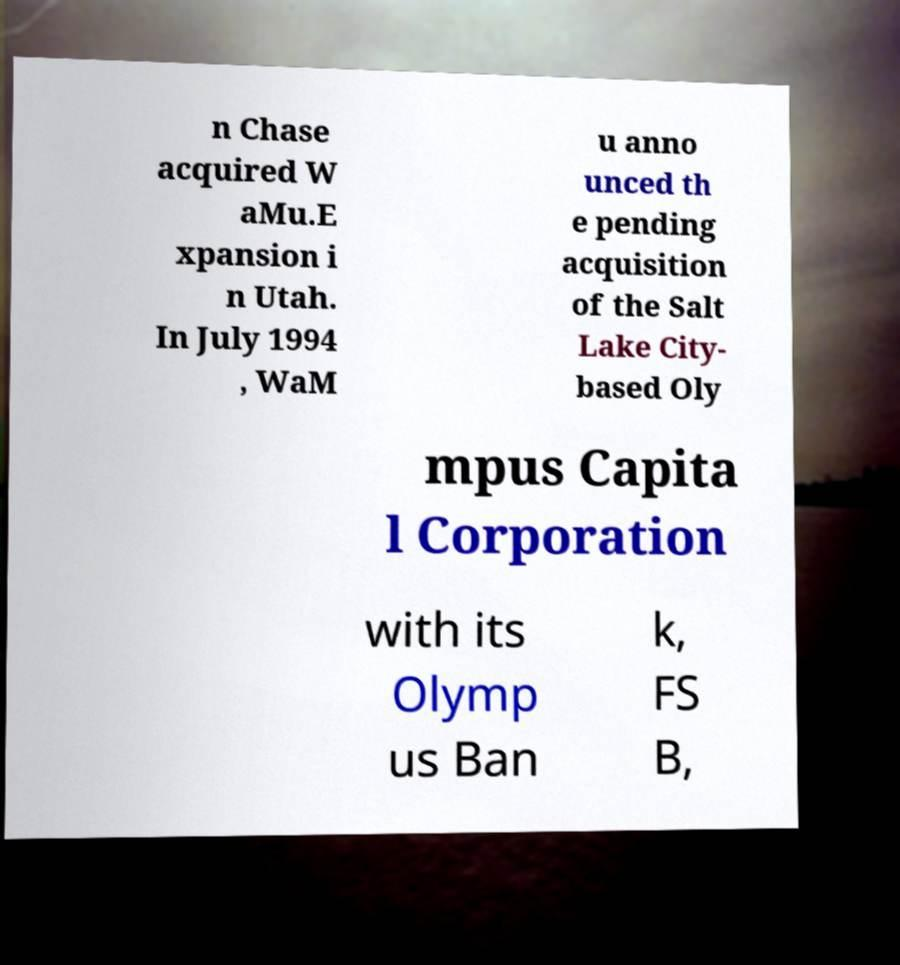What messages or text are displayed in this image? I need them in a readable, typed format. n Chase acquired W aMu.E xpansion i n Utah. In July 1994 , WaM u anno unced th e pending acquisition of the Salt Lake City- based Oly mpus Capita l Corporation with its Olymp us Ban k, FS B, 